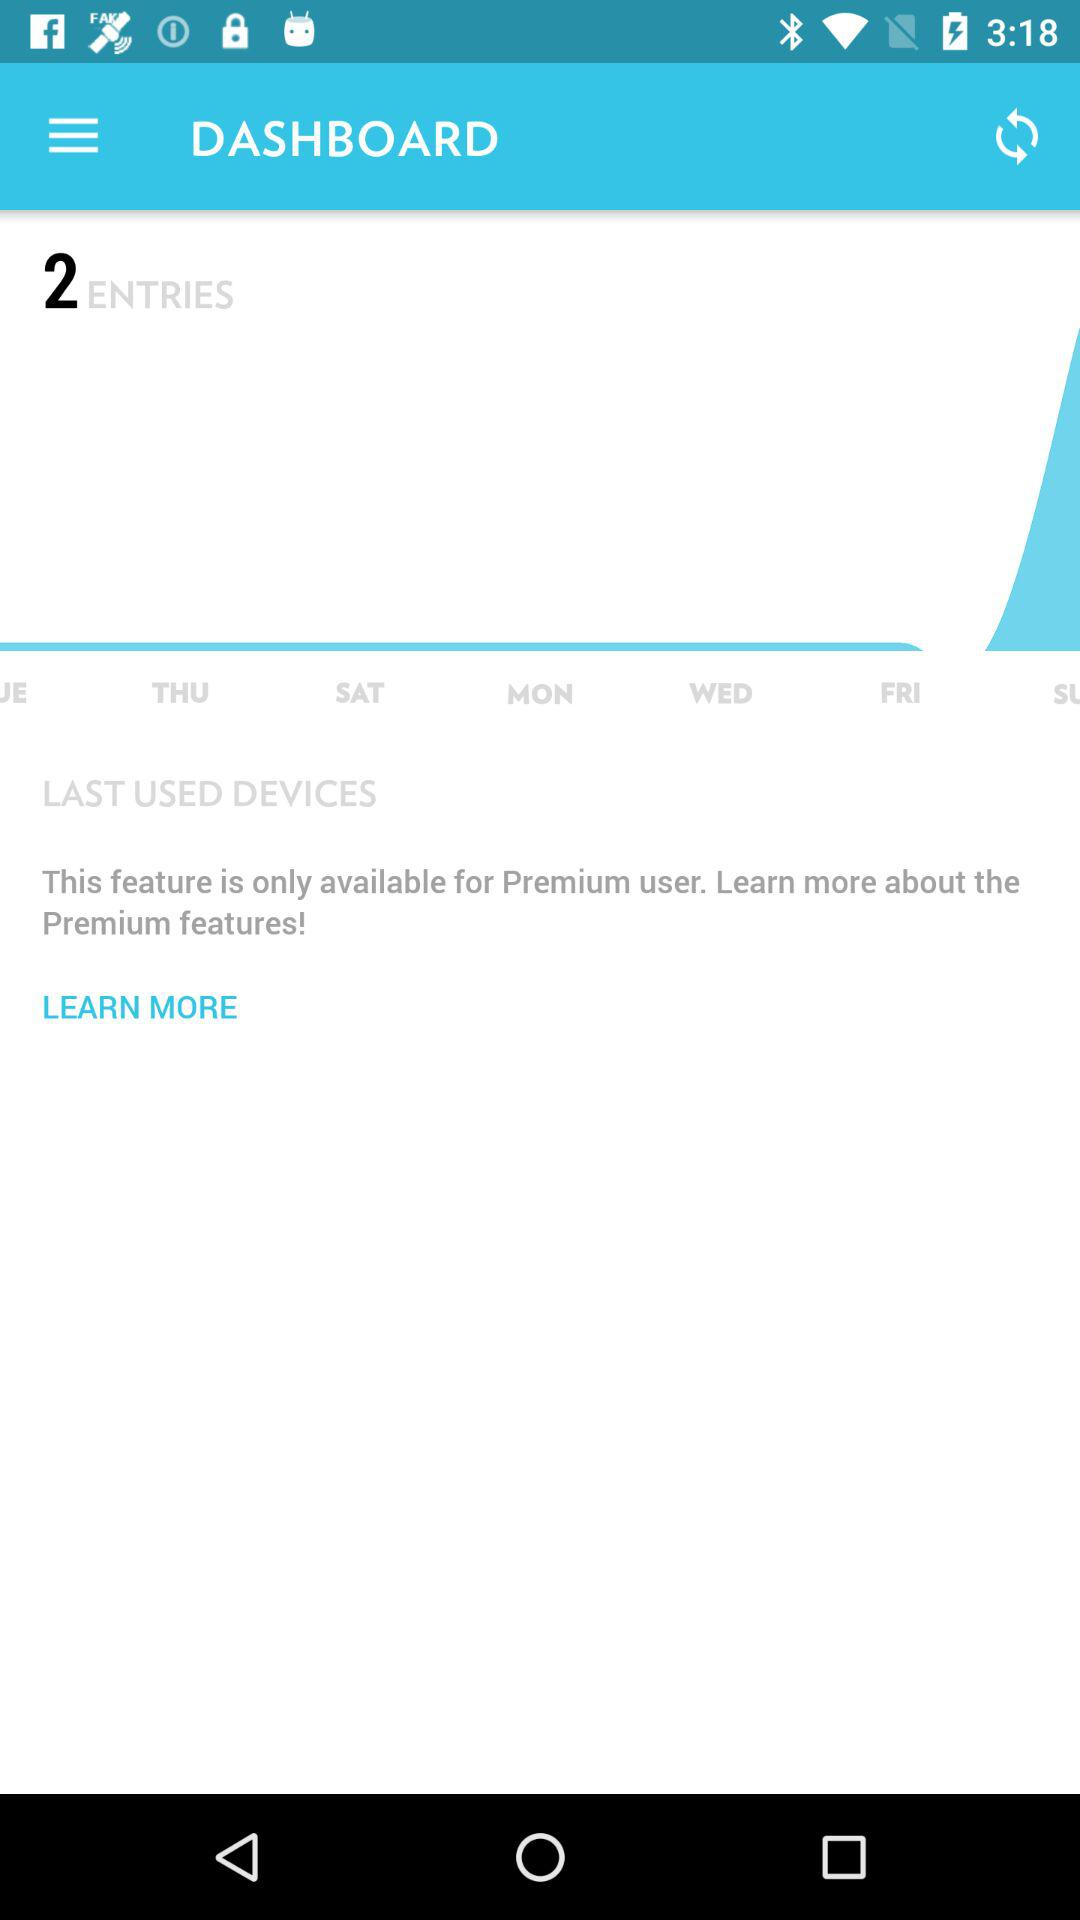Which feature is only available for premium user?
When the provided information is insufficient, respond with <no answer>. <no answer> 